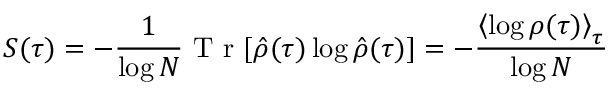Convert formula to latex. <formula><loc_0><loc_0><loc_500><loc_500>S ( \tau ) = - \frac { 1 } { \log N } T r [ \hat { \rho } ( \tau ) \log \hat { \rho } ( \tau ) ] = - \frac { \left < \log \rho ( \tau ) \right > _ { \tau } } { \log N }</formula> 